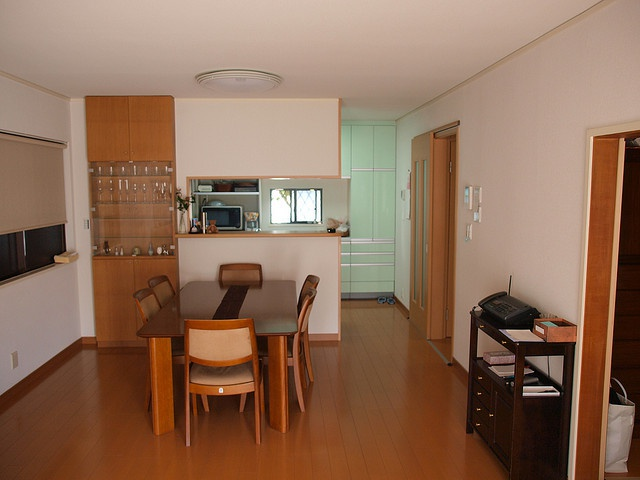Describe the objects in this image and their specific colors. I can see dining table in darkgray, maroon, brown, and black tones, chair in darkgray, maroon, tan, and brown tones, chair in darkgray, maroon, black, and brown tones, handbag in darkgray, gray, and black tones, and chair in darkgray, maroon, and black tones in this image. 